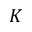<formula> <loc_0><loc_0><loc_500><loc_500>K</formula> 